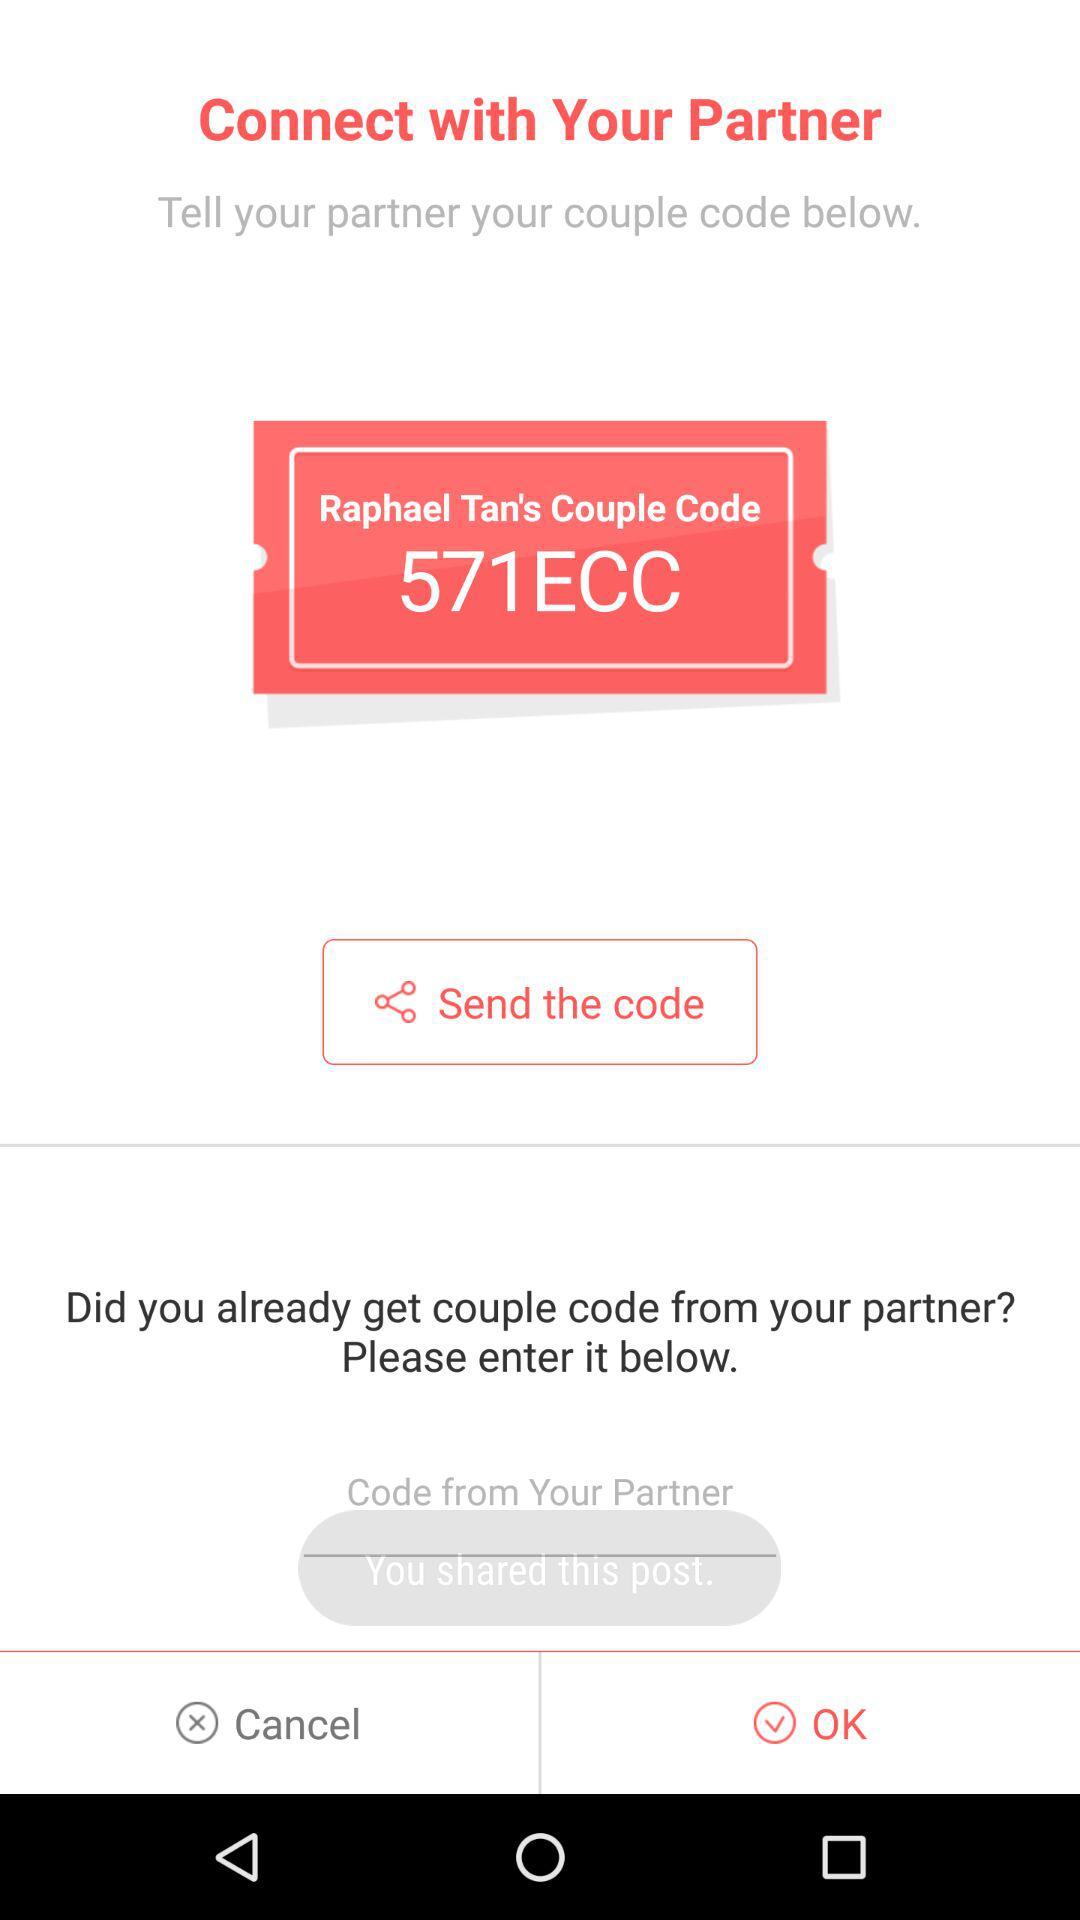What is the couple code of Raphael Tan? The couple code of Raphael Tan is "571ECC". 